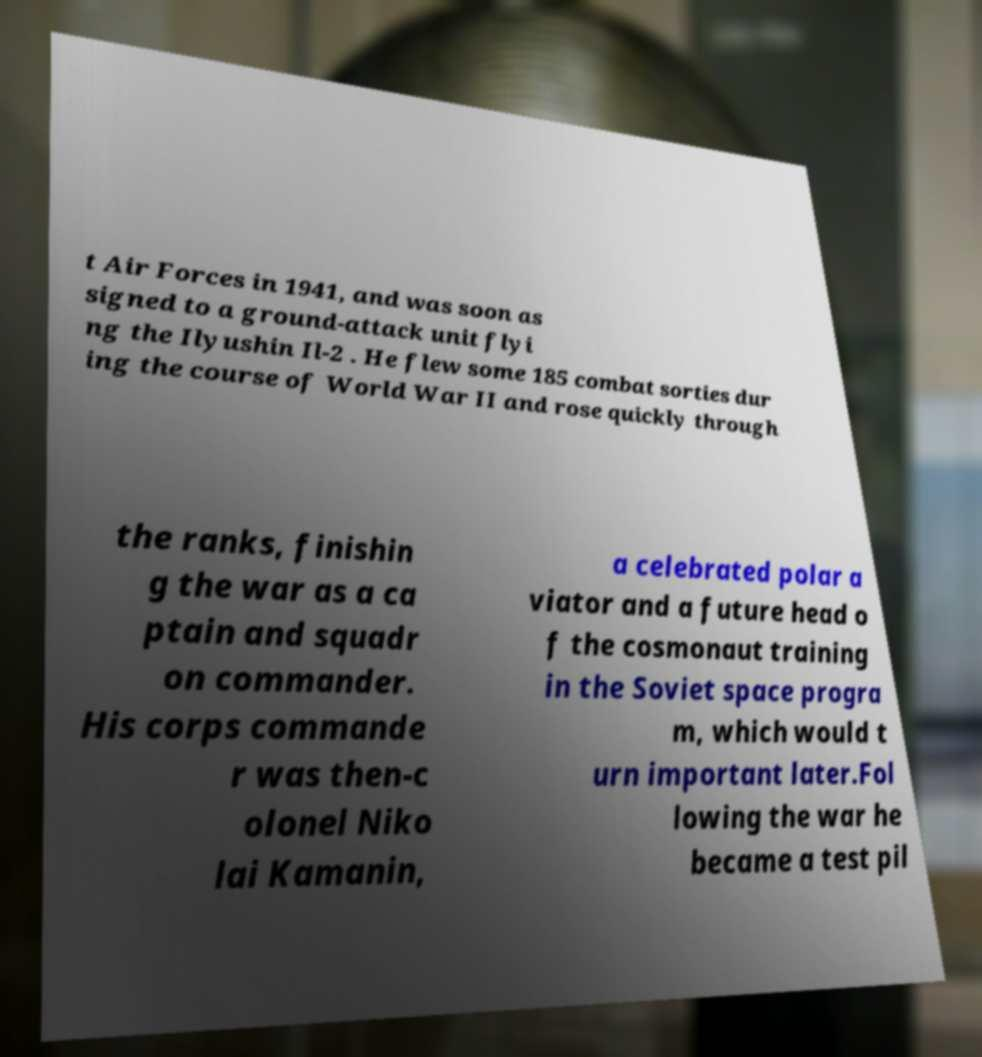I need the written content from this picture converted into text. Can you do that? t Air Forces in 1941, and was soon as signed to a ground-attack unit flyi ng the Ilyushin Il-2 . He flew some 185 combat sorties dur ing the course of World War II and rose quickly through the ranks, finishin g the war as a ca ptain and squadr on commander. His corps commande r was then-c olonel Niko lai Kamanin, a celebrated polar a viator and a future head o f the cosmonaut training in the Soviet space progra m, which would t urn important later.Fol lowing the war he became a test pil 